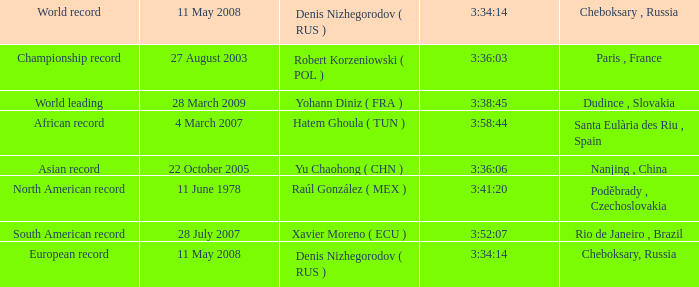When 3:38:45 is  3:34:14 what is the date on May 11th, 2008? 28 March 2009. 